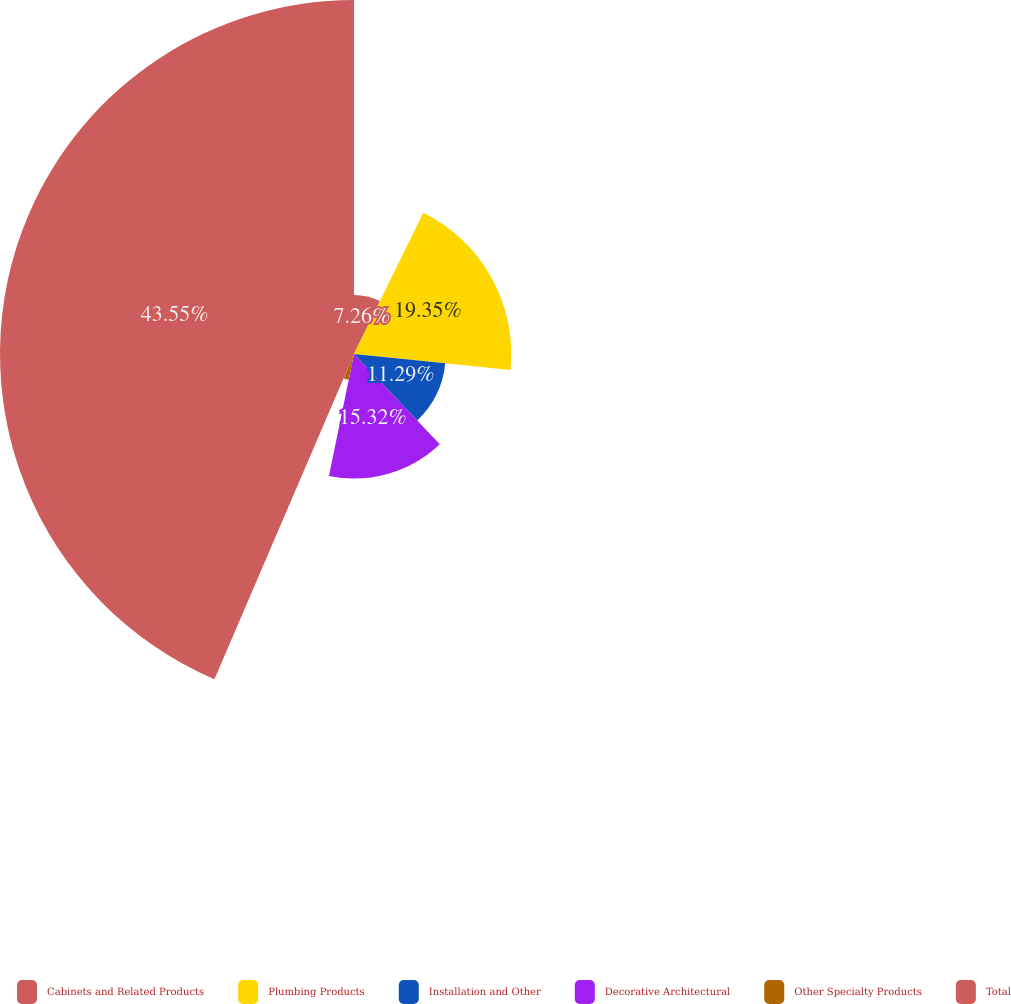<chart> <loc_0><loc_0><loc_500><loc_500><pie_chart><fcel>Cabinets and Related Products<fcel>Plumbing Products<fcel>Installation and Other<fcel>Decorative Architectural<fcel>Other Specialty Products<fcel>Total<nl><fcel>7.26%<fcel>19.35%<fcel>11.29%<fcel>15.32%<fcel>3.23%<fcel>43.55%<nl></chart> 